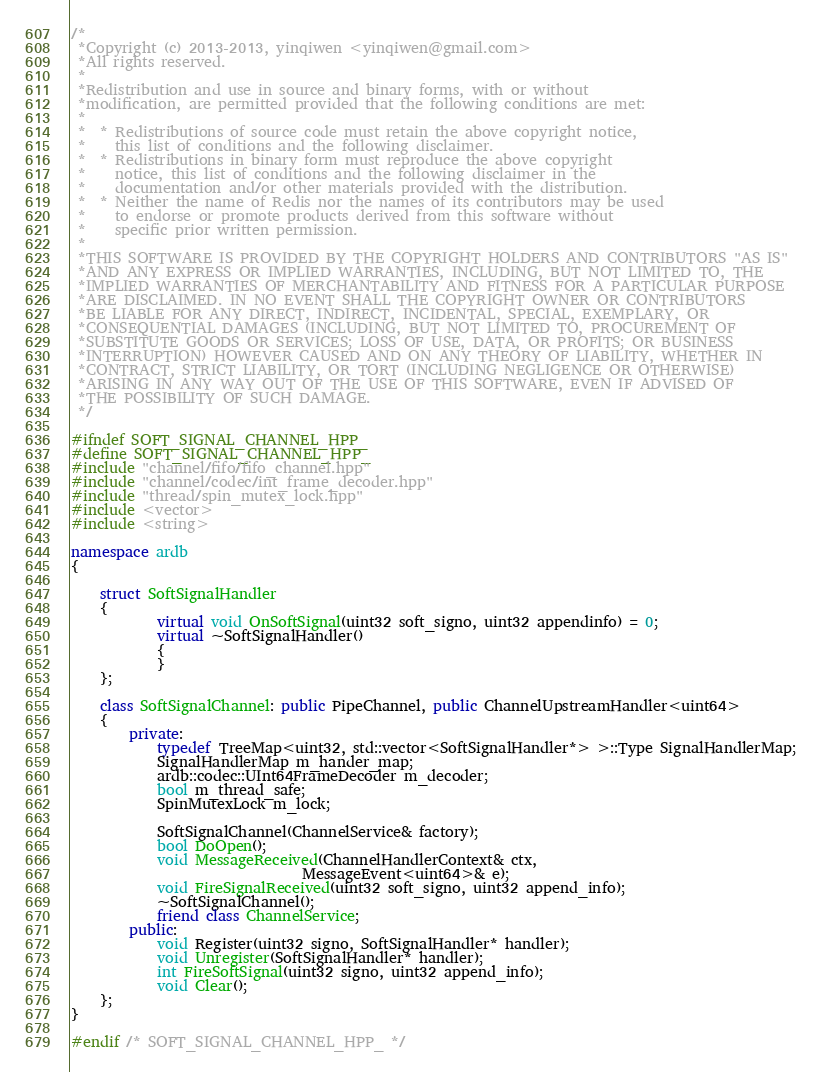Convert code to text. <code><loc_0><loc_0><loc_500><loc_500><_C++_>/*
 *Copyright (c) 2013-2013, yinqiwen <yinqiwen@gmail.com>
 *All rights reserved.
 * 
 *Redistribution and use in source and binary forms, with or without
 *modification, are permitted provided that the following conditions are met:
 * 
 *  * Redistributions of source code must retain the above copyright notice,
 *    this list of conditions and the following disclaimer.
 *  * Redistributions in binary form must reproduce the above copyright
 *    notice, this list of conditions and the following disclaimer in the
 *    documentation and/or other materials provided with the distribution.
 *  * Neither the name of Redis nor the names of its contributors may be used
 *    to endorse or promote products derived from this software without
 *    specific prior written permission.
 * 
 *THIS SOFTWARE IS PROVIDED BY THE COPYRIGHT HOLDERS AND CONTRIBUTORS "AS IS"
 *AND ANY EXPRESS OR IMPLIED WARRANTIES, INCLUDING, BUT NOT LIMITED TO, THE
 *IMPLIED WARRANTIES OF MERCHANTABILITY AND FITNESS FOR A PARTICULAR PURPOSE
 *ARE DISCLAIMED. IN NO EVENT SHALL THE COPYRIGHT OWNER OR CONTRIBUTORS 
 *BE LIABLE FOR ANY DIRECT, INDIRECT, INCIDENTAL, SPECIAL, EXEMPLARY, OR
 *CONSEQUENTIAL DAMAGES (INCLUDING, BUT NOT LIMITED TO, PROCUREMENT OF
 *SUBSTITUTE GOODS OR SERVICES; LOSS OF USE, DATA, OR PROFITS; OR BUSINESS
 *INTERRUPTION) HOWEVER CAUSED AND ON ANY THEORY OF LIABILITY, WHETHER IN
 *CONTRACT, STRICT LIABILITY, OR TORT (INCLUDING NEGLIGENCE OR OTHERWISE)
 *ARISING IN ANY WAY OUT OF THE USE OF THIS SOFTWARE, EVEN IF ADVISED OF 
 *THE POSSIBILITY OF SUCH DAMAGE.
 */

#ifndef SOFT_SIGNAL_CHANNEL_HPP_
#define SOFT_SIGNAL_CHANNEL_HPP_
#include "channel/fifo/fifo_channel.hpp"
#include "channel/codec/int_frame_decoder.hpp"
#include "thread/spin_mutex_lock.hpp"
#include <vector>
#include <string>

namespace ardb
{

	struct SoftSignalHandler
	{
			virtual void OnSoftSignal(uint32 soft_signo, uint32 appendinfo) = 0;
			virtual ~SoftSignalHandler()
			{
			}
	};

	class SoftSignalChannel: public PipeChannel, public ChannelUpstreamHandler<uint64>
	{
		private:
			typedef TreeMap<uint32, std::vector<SoftSignalHandler*> >::Type SignalHandlerMap;
			SignalHandlerMap m_hander_map;
			ardb::codec::UInt64FrameDecoder m_decoder;
			bool m_thread_safe;
			SpinMutexLock m_lock;

			SoftSignalChannel(ChannelService& factory);
			bool DoOpen();
			void MessageReceived(ChannelHandlerContext& ctx,
								MessageEvent<uint64>& e);
			void FireSignalReceived(uint32 soft_signo, uint32 append_info);
			~SoftSignalChannel();
			friend class ChannelService;
		public:
			void Register(uint32 signo, SoftSignalHandler* handler);
			void Unregister(SoftSignalHandler* handler);
			int FireSoftSignal(uint32 signo, uint32 append_info);
			void Clear();
	};
}

#endif /* SOFT_SIGNAL_CHANNEL_HPP_ */
</code> 